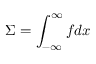Convert formula to latex. <formula><loc_0><loc_0><loc_500><loc_500>\Sigma = \int _ { - \infty } ^ { \infty } f d x</formula> 